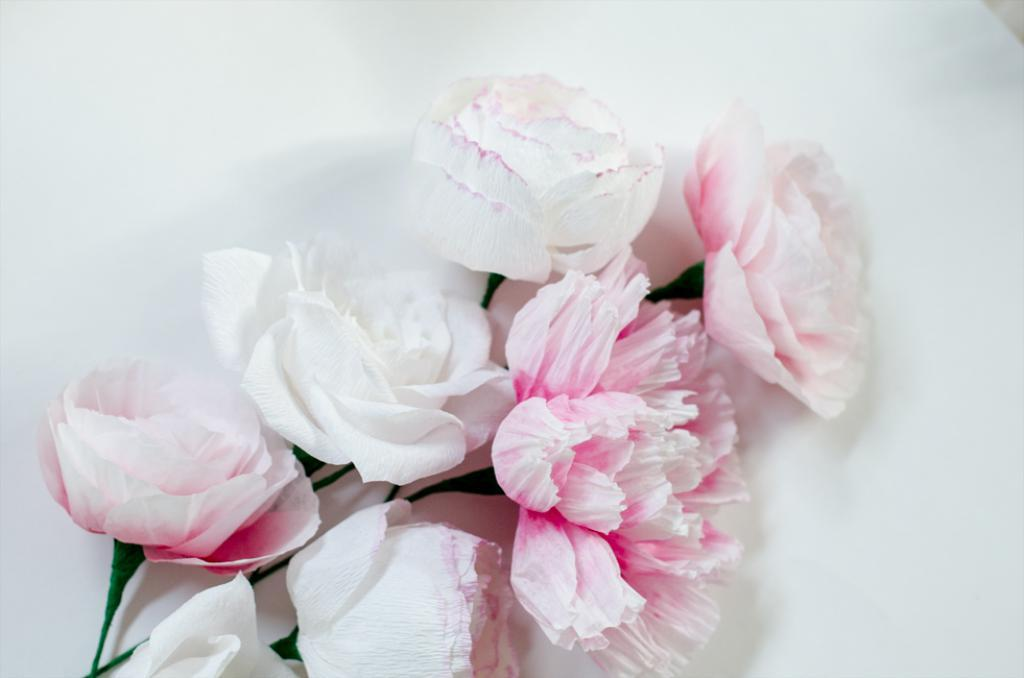What colors are the flowers in the image? The flowers in the image are white and pink. Where are the flowers located in the image? The flowers are in the middle of the image. What color is the background of the image? The background of the image is white. What type of haircut is the flower receiving in the image? There is no haircut being performed in the image, as flowers do not have hair. 